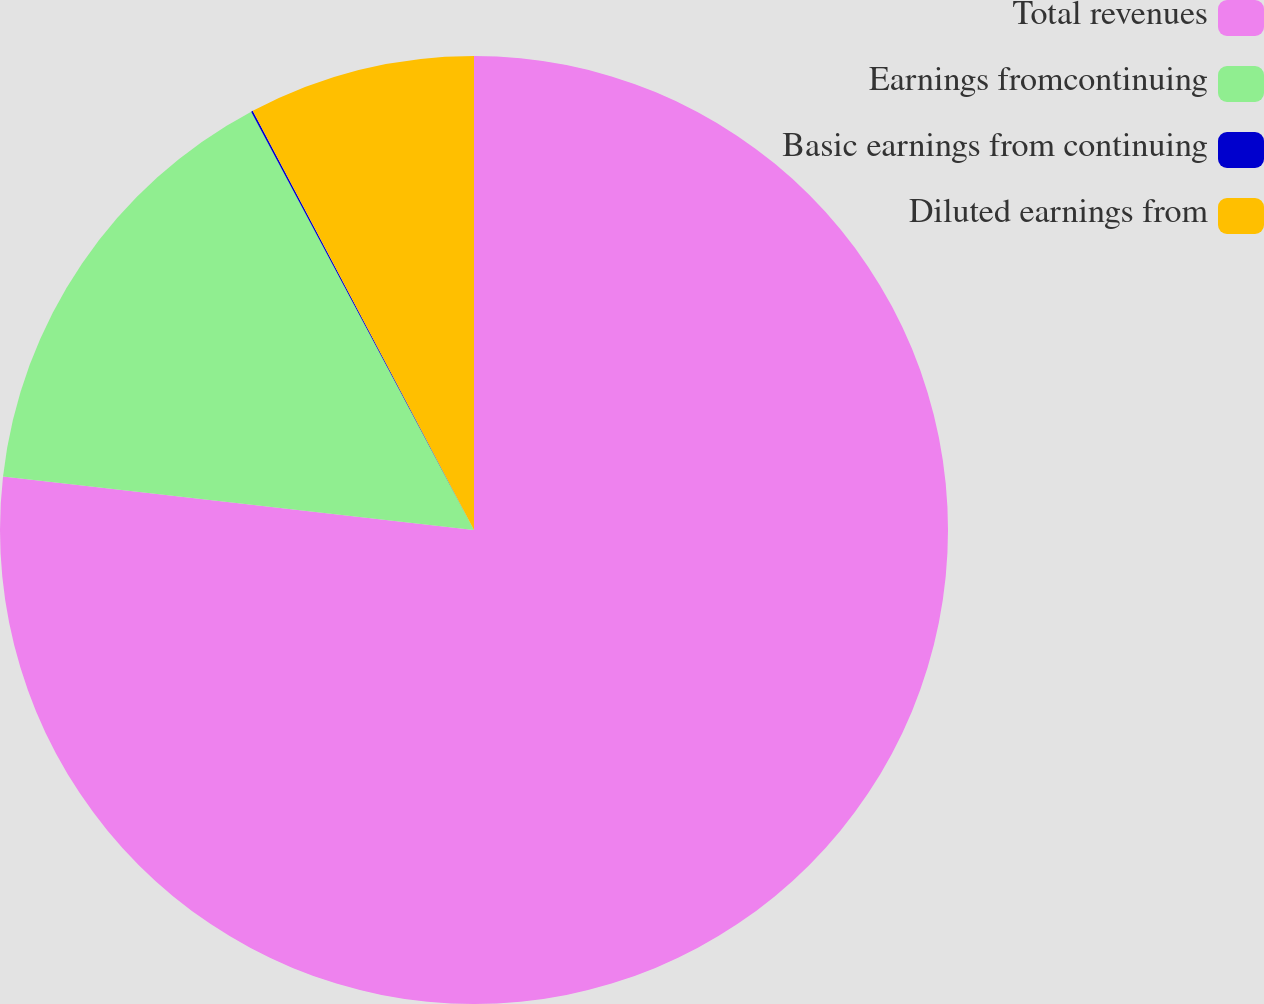Convert chart. <chart><loc_0><loc_0><loc_500><loc_500><pie_chart><fcel>Total revenues<fcel>Earnings fromcontinuing<fcel>Basic earnings from continuing<fcel>Diluted earnings from<nl><fcel>76.81%<fcel>15.41%<fcel>0.06%<fcel>7.73%<nl></chart> 